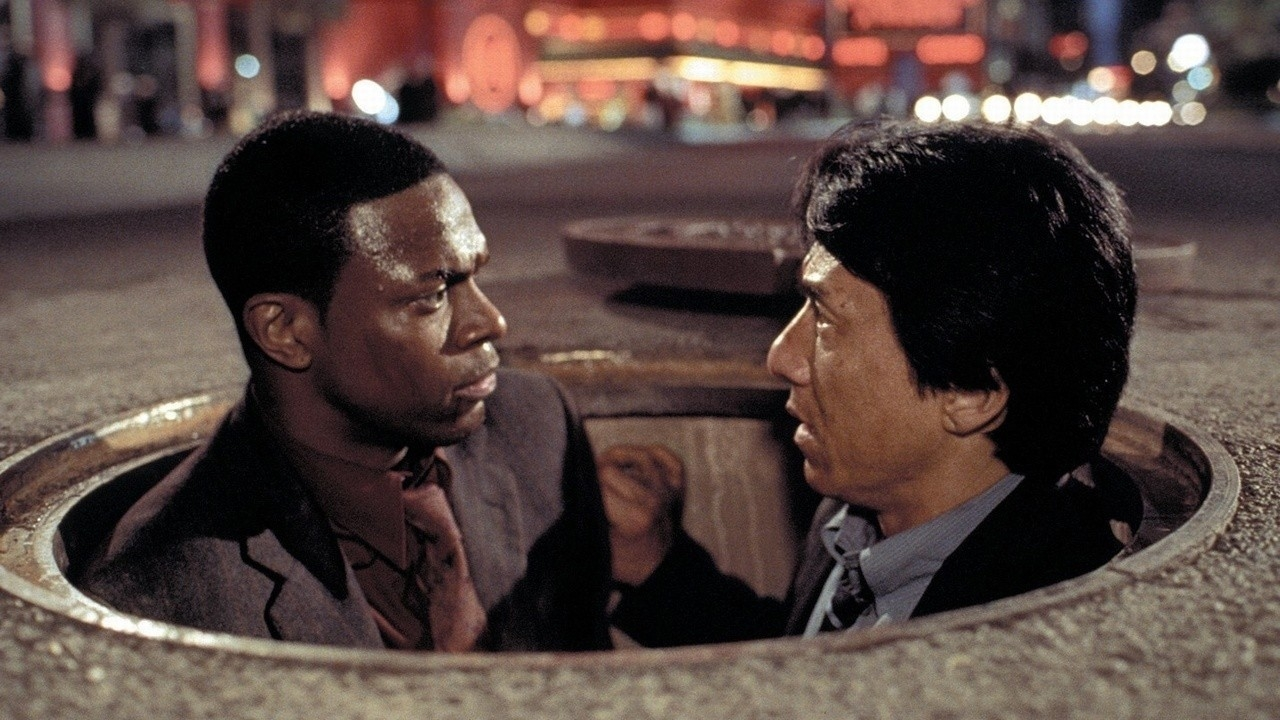What conversation might they be having in this scene? Chris Tucker: "Man, I told you we shouldn't have taken that detour! Now look where we are, stuck in a manhole with no backup." 
Jackie Chan: "Calm down, Carter. We're still one step ahead of them. We just need to figure out our next move carefully." 
Chris Tucker: "Easy for you to say, you're used to this kind of crazy stuff. We need to get out of here and fast!" 
Jackie Chan: "Trust me, I have a plan. But first, we need to use this manhole to our advantage. They'll never expect it." 